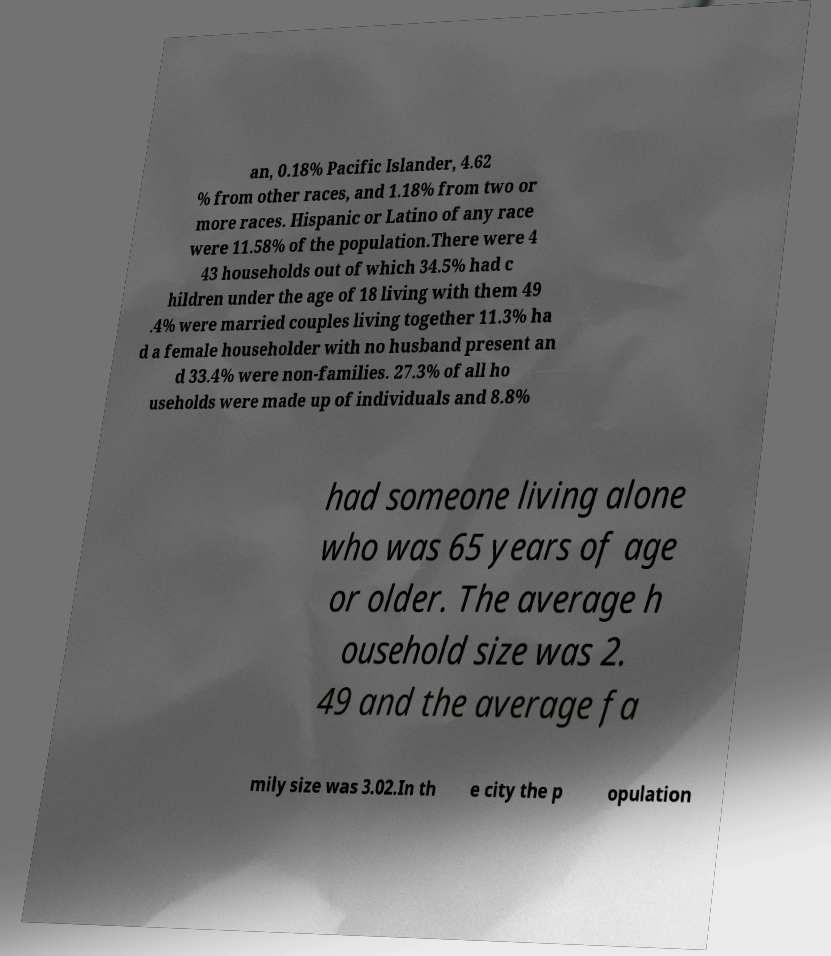Could you extract and type out the text from this image? an, 0.18% Pacific Islander, 4.62 % from other races, and 1.18% from two or more races. Hispanic or Latino of any race were 11.58% of the population.There were 4 43 households out of which 34.5% had c hildren under the age of 18 living with them 49 .4% were married couples living together 11.3% ha d a female householder with no husband present an d 33.4% were non-families. 27.3% of all ho useholds were made up of individuals and 8.8% had someone living alone who was 65 years of age or older. The average h ousehold size was 2. 49 and the average fa mily size was 3.02.In th e city the p opulation 